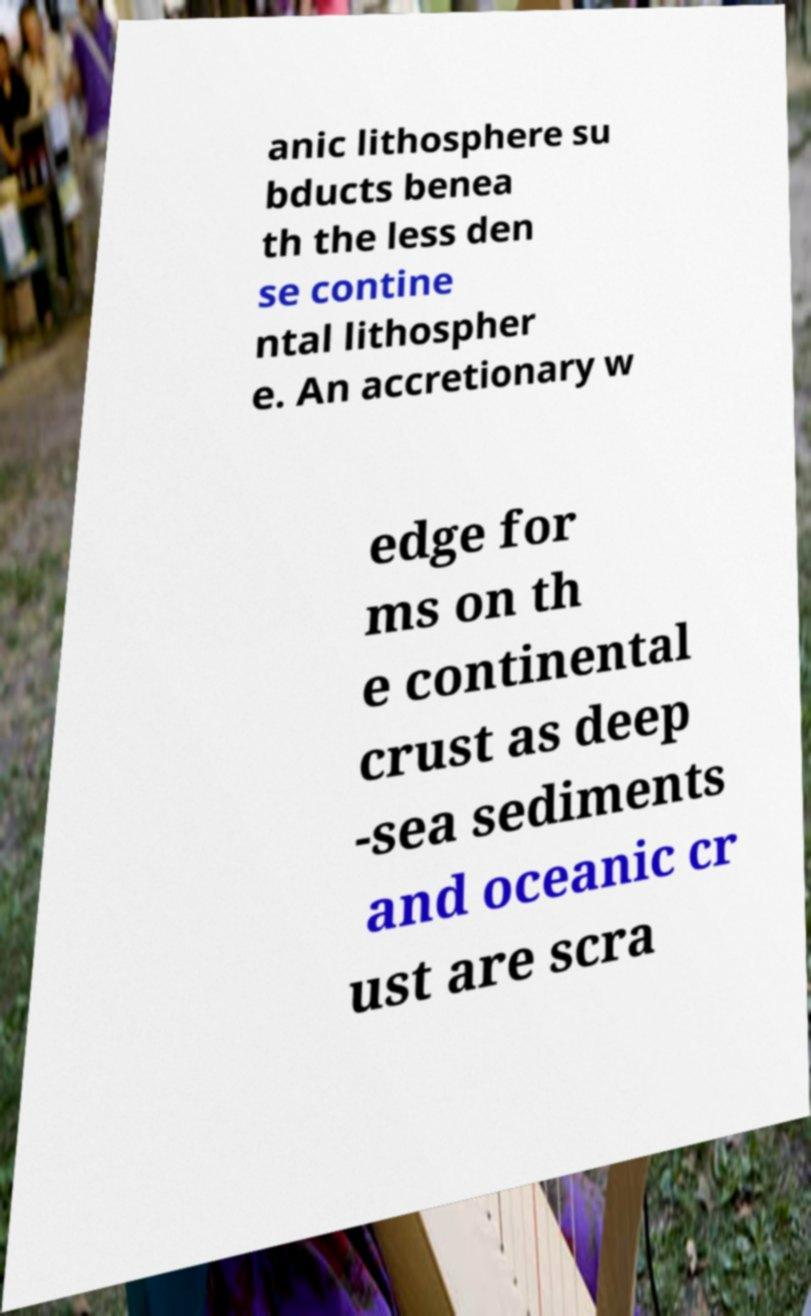For documentation purposes, I need the text within this image transcribed. Could you provide that? anic lithosphere su bducts benea th the less den se contine ntal lithospher e. An accretionary w edge for ms on th e continental crust as deep -sea sediments and oceanic cr ust are scra 